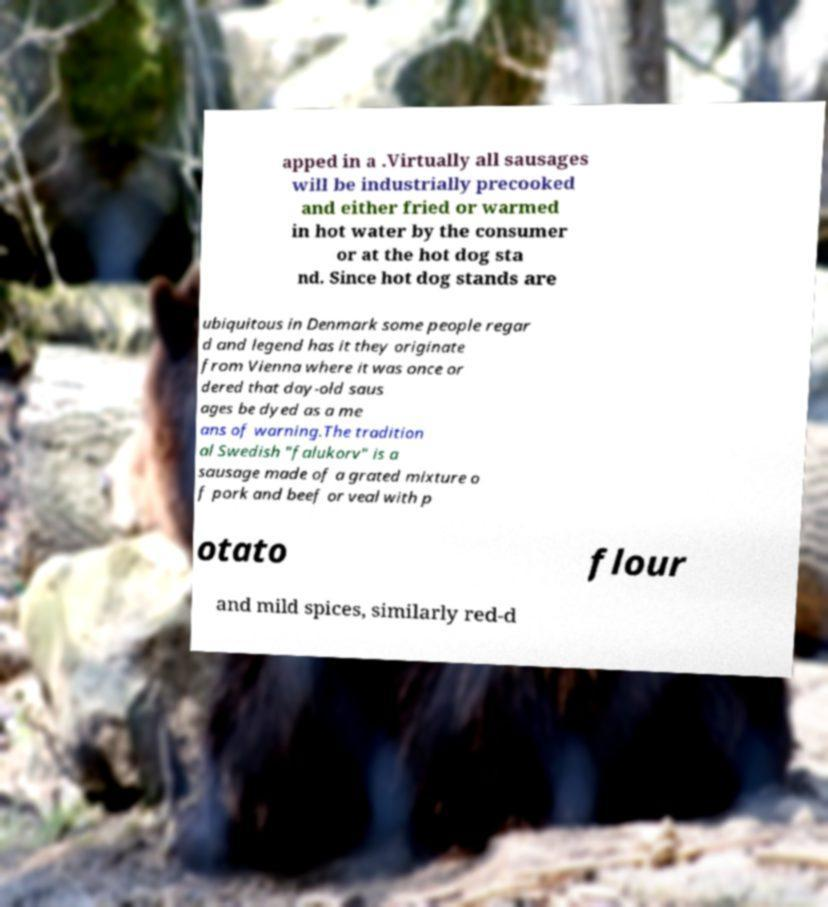Can you accurately transcribe the text from the provided image for me? apped in a .Virtually all sausages will be industrially precooked and either fried or warmed in hot water by the consumer or at the hot dog sta nd. Since hot dog stands are ubiquitous in Denmark some people regar d and legend has it they originate from Vienna where it was once or dered that day-old saus ages be dyed as a me ans of warning.The tradition al Swedish "falukorv" is a sausage made of a grated mixture o f pork and beef or veal with p otato flour and mild spices, similarly red-d 